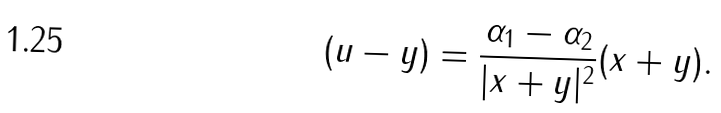Convert formula to latex. <formula><loc_0><loc_0><loc_500><loc_500>( { u } - { y } ) = \frac { \alpha _ { 1 } - \alpha _ { 2 } } { | { x } + { y } | ^ { 2 } } ( { x } + { y } ) .</formula> 